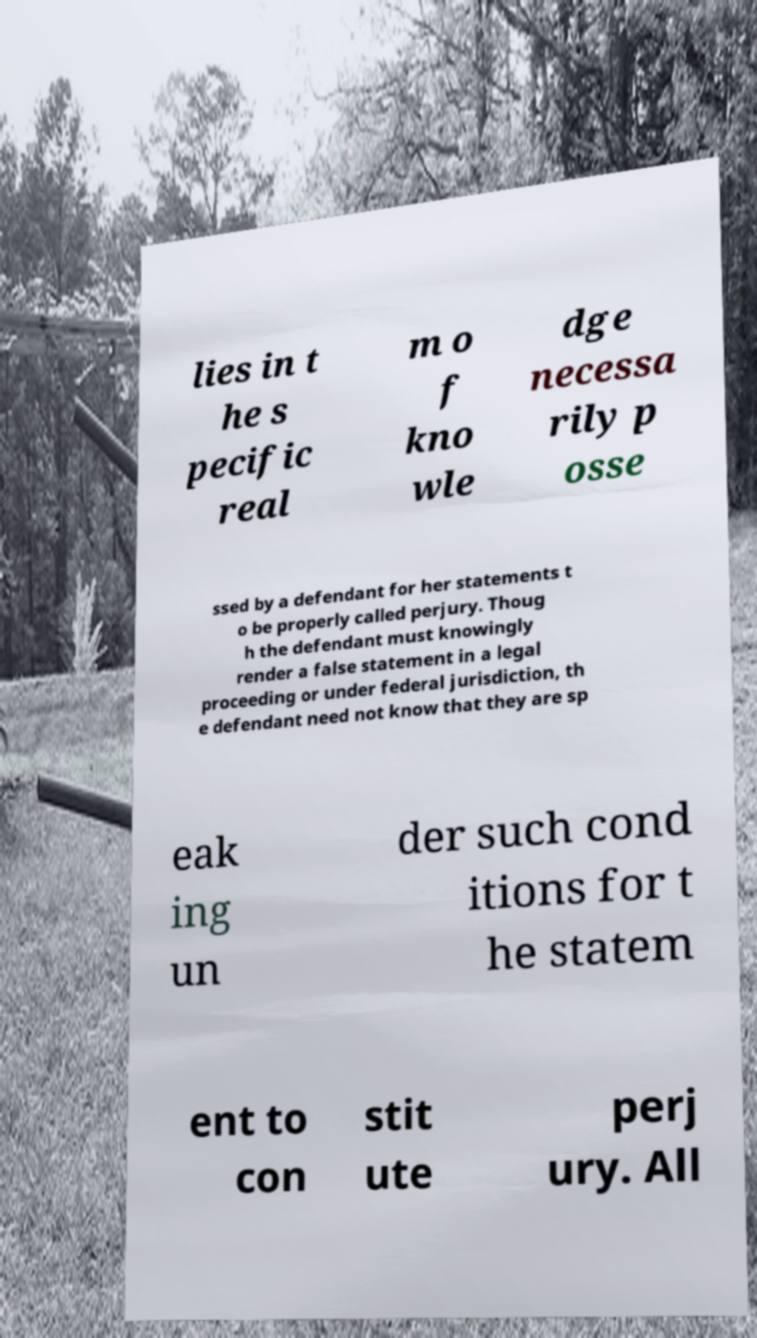What messages or text are displayed in this image? I need them in a readable, typed format. lies in t he s pecific real m o f kno wle dge necessa rily p osse ssed by a defendant for her statements t o be properly called perjury. Thoug h the defendant must knowingly render a false statement in a legal proceeding or under federal jurisdiction, th e defendant need not know that they are sp eak ing un der such cond itions for t he statem ent to con stit ute perj ury. All 